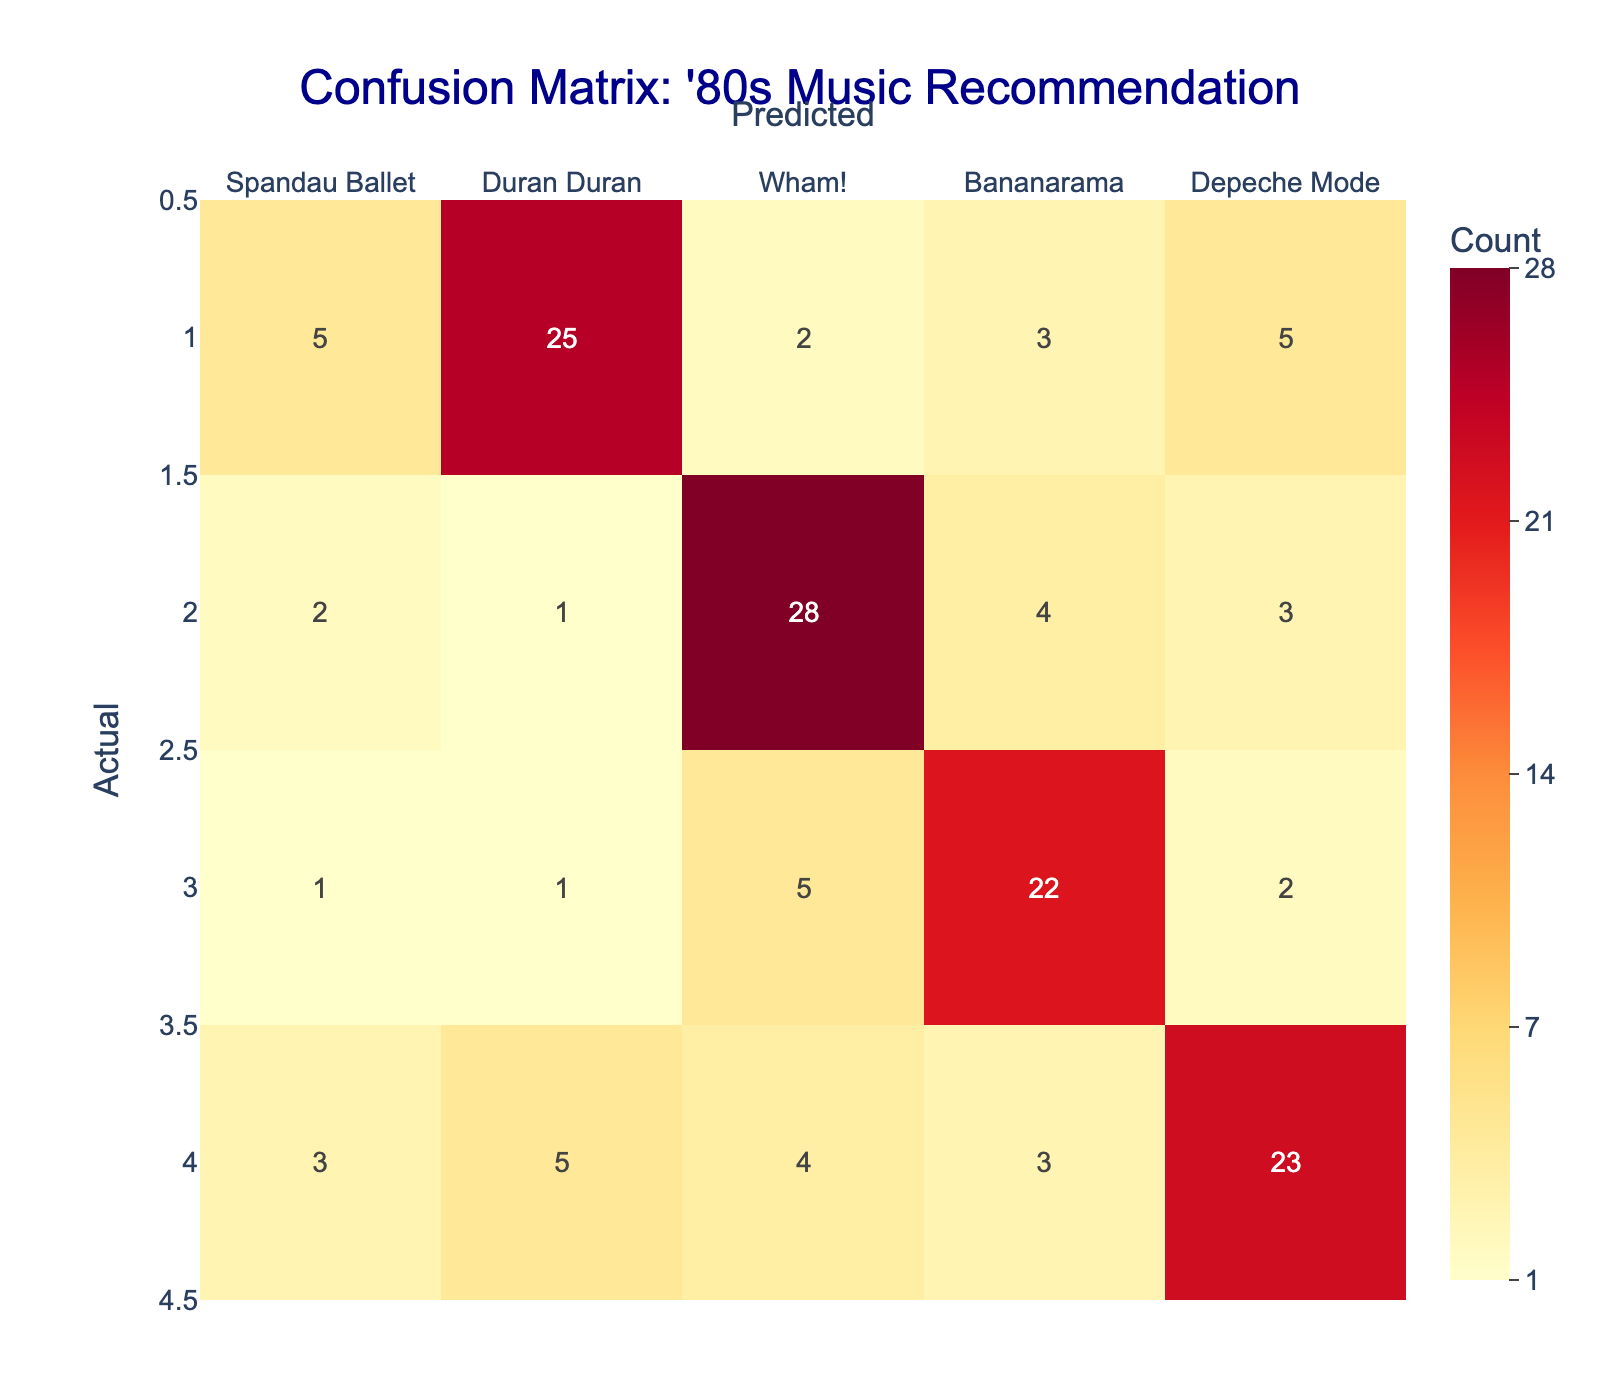What is the total number of times Spandau Ballet was correctly predicted? To find the total number of correct predictions for Spandau Ballet, we look at the cell in the row for Spandau Ballet and the column for Spandau Ballet, which shows 30. This number represents the true positives for Spandau Ballet.
Answer: 30 What is the number of times Duran Duran was incorrectly predicted as Wham!? To find this value, we check the row for Duran Duran and the column for Wham!. The value at this intersection is 2, which indicates that Duran Duran was mistakenly predicted as Wham! twice.
Answer: 2 Is it true that Bananarama had more correct predictions than Depeche Mode? We check the correct predictions for both Bananarama and Depeche Mode. Bananarama's correct prediction count is 22, while Depeche Mode's is 23, thus Bananarama had fewer correct predictions than Depeche Mode. Therefore, the statement is false.
Answer: No What was the total number of predictions for Wham!? To find the total predictions for Wham!, we sum all values in the Wham! column. This includes 1 (correct prediction), 2, 28, 5, and 4 from the actual categories Spandau Ballet, Duran Duran, Wham!, Bananarama, and Depeche Mode, respectively. The total is 1 + 2 + 28 + 5 + 4 = 40.
Answer: 40 Which artist had the highest number of incorrect predictions? To determine this, we need to analyze the total of off-diagonal values (incorrect predictions) for each artist. For Spandau Ballet: 3 + 1 + 2 + 4 = 10; Duran Duran: 5 + 2 + 3 + 5 = 15; Wham!: 2 + 1 + 4 + 3 = 10; Bananarama: 1 + 1 + 5 + 2 = 9; Depeche Mode: 3 + 5 + 4 + 3 = 15. Duran Duran and Depeche Mode both had the highest incorrect predictions, totaling 15 each.
Answer: Duran Duran and Depeche Mode (15) What is the sum of all correct predictions across all artists? To find the sum of correct predictions, we take the values along the diagonal of the confusion matrix: 30 (Spandau Ballet) + 25 (Duran Duran) + 28 (Wham!) + 22 (Bananarama) + 23 (Depeche Mode). The total correct predictions is 30 + 25 + 28 + 22 + 23 = 128.
Answer: 128 